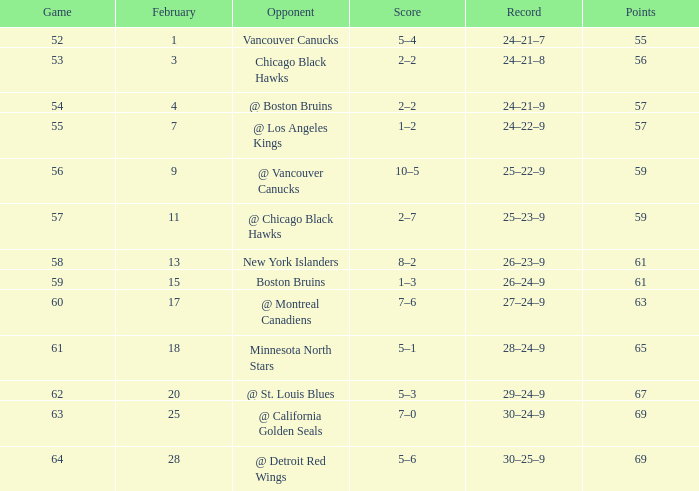How many games possess a 30-25-9 record and a point total greater than 69? 0.0. 